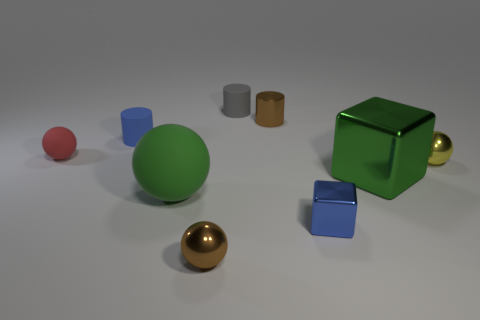Are there an equal number of red matte things that are behind the blue matte cylinder and green rubber things that are to the left of the big sphere?
Your answer should be compact. Yes. Is there a blue matte cylinder of the same size as the red object?
Give a very brief answer. Yes. What size is the red thing?
Provide a short and direct response. Small. Is the number of gray rubber objects that are right of the large green sphere the same as the number of yellow spheres?
Your response must be concise. Yes. How many other objects are there of the same color as the tiny matte ball?
Your answer should be very brief. 0. What is the color of the ball that is both behind the green shiny object and to the left of the small yellow shiny ball?
Provide a short and direct response. Red. What size is the brown metallic thing behind the small object that is left of the small cylinder that is in front of the brown shiny cylinder?
Your answer should be compact. Small. How many objects are either rubber balls right of the red rubber thing or brown things to the right of the tiny brown metal sphere?
Keep it short and to the point. 2. What shape is the green metal object?
Your response must be concise. Cube. What number of other objects are there of the same material as the tiny gray cylinder?
Provide a short and direct response. 3. 